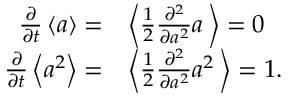<formula> <loc_0><loc_0><loc_500><loc_500>\begin{array} { r l } { \frac { \partial } { \partial t } \left \langle a \right \rangle = } & { \left \langle \frac { 1 } { 2 } \frac { \partial ^ { 2 } } { \partial a ^ { 2 } } a \, \right \rangle = 0 } \\ { \frac { \partial } { \partial t } \left \langle a ^ { 2 } \right \rangle = } & { \left \langle \frac { 1 } { 2 } \frac { \partial ^ { 2 } } { \partial a ^ { 2 } } a ^ { 2 } \, \right \rangle = 1 . } \end{array}</formula> 